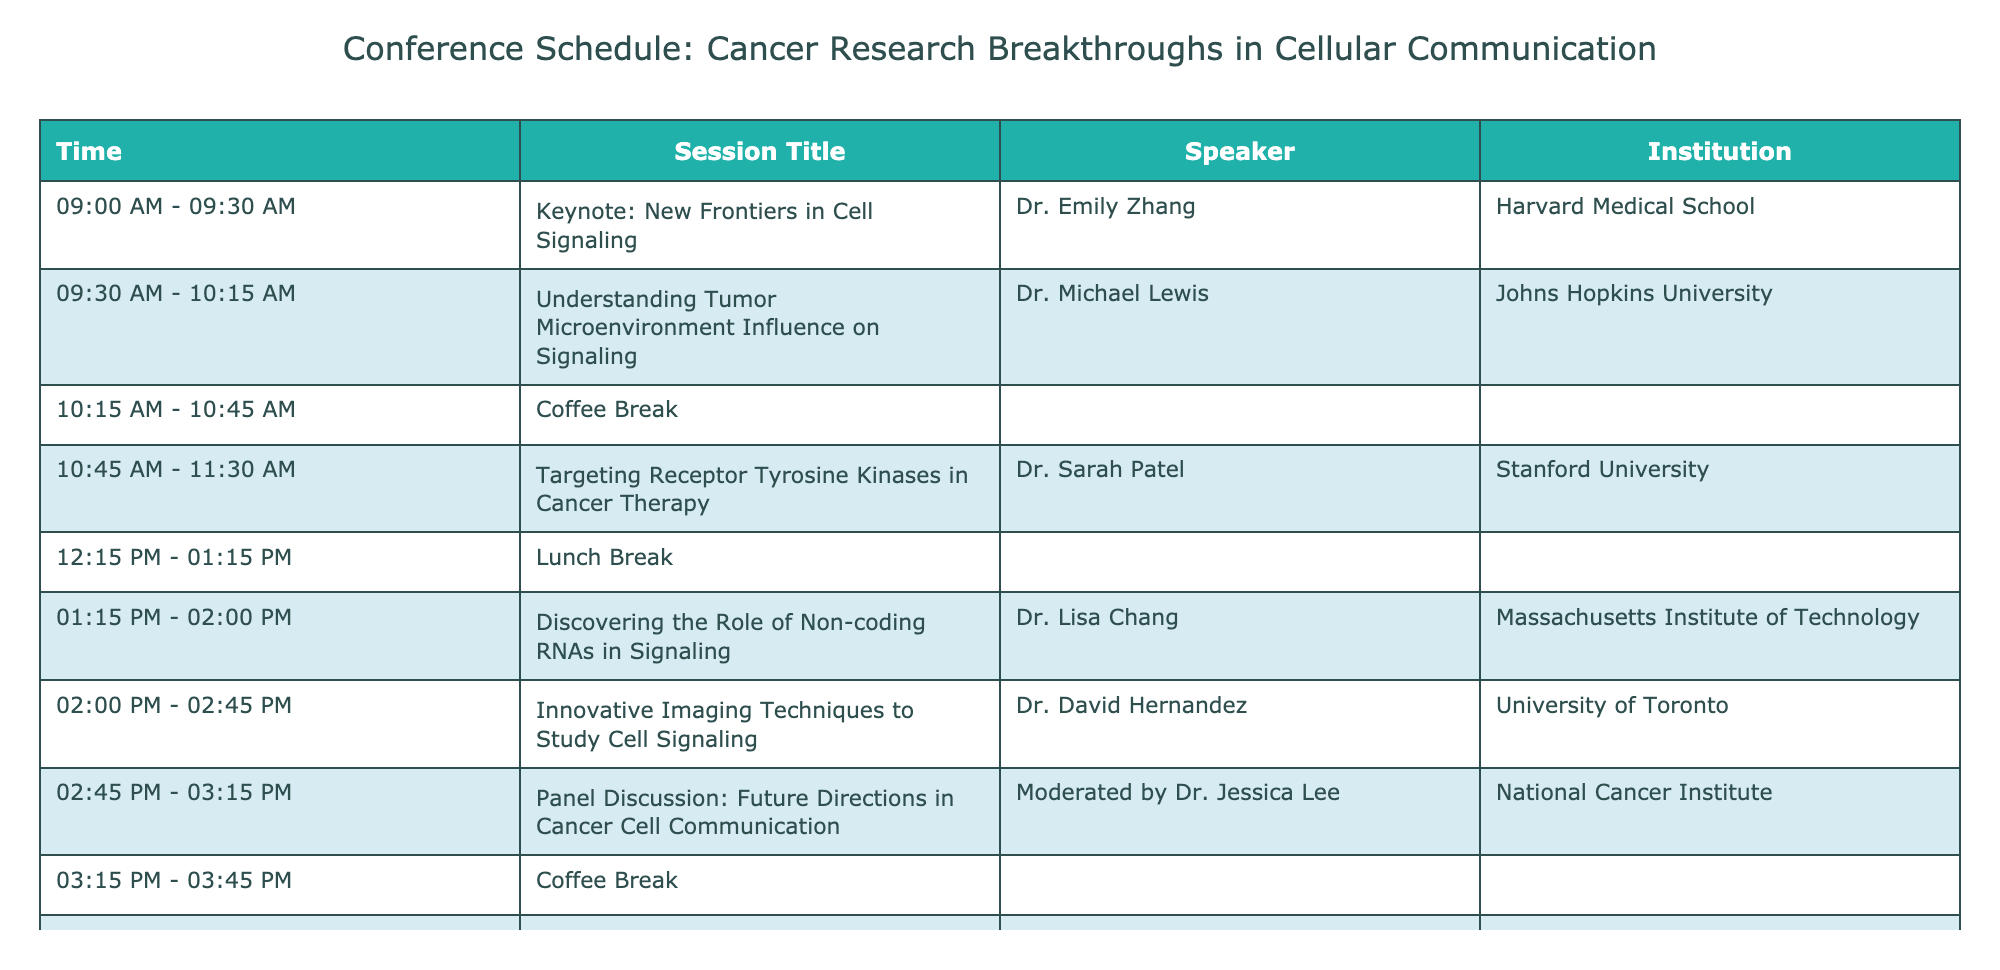What time does the keynote session start? The keynote session titled "New Frontiers in Cell Signaling" starts at 09:00 AM as listed in the 'Time' column next to the corresponding session title.
Answer: 09:00 AM Who is the speaker for the session on receptor tyrosine kinases? The session titled "Targeting Receptor Tyrosine Kinases in Cancer Therapy" features Dr. Sarah Patel as the speaker, which can be directly found in the 'Speaker' column aligned with that session title.
Answer: Dr. Sarah Patel How many sessions are scheduled after the lunch break? After the lunch break at 12:15 PM, there are three sessions: "Discovering the Role of Non-coding RNAs in Signaling," "Innovative Imaging Techniques to Study Cell Signaling," and "Panel Discussion: Future Directions in Cancer Cell Communication." Counting these sessions results in three.
Answer: 3 Is there a session discussing the tumor microenvironment? Yes, there is a session titled "Understanding Tumor Microenvironment Influence on Signaling" led by Dr. Michael Lewis, which indicates that this topic is addressed among the conference agenda.
Answer: Yes What is the duration of the coffee breaks in total? There are two coffee breaks scheduled—one from 10:15 AM to 10:45 AM (30 minutes) and another from 03:15 PM to 03:45 PM (30 minutes). Adding these two durations together gives a total coffee break time of 30 + 30 = 60 minutes.
Answer: 60 minutes Which institution is Dr. David Hernandez affiliated with? Dr. David Hernandez, who presents a session on "Innovative Imaging Techniques to Study Cell Signaling," is affiliated with the University of Toronto, as indicated in the 'Institution' column next to his name.
Answer: University of Toronto What session immediately follows the panel discussion? The session that immediately follows the panel discussion titled "Future Directions in Cancer Cell Communication" starts at 03:45 PM and is focused on utilizing CRISPR for signaling pathway discovery. This can be seen in the timeline where "Utilizing CRISPR for Signaling Pathway Discovery" is listed next.
Answer: Utilizing CRISPR for Signaling Pathway Discovery How many speakers are affiliated with Harvard Medical School? The only speaker listed from Harvard Medical School is Dr. Emily Zhang, who delivers the keynote session. Therefore, there is only one speaker from that institution according to the table.
Answer: 1 What is the title of the session directed by Dr. Lisa Chang? The session led by Dr. Lisa Chang is titled "Discovering the Role of Non-coding RNAs in Signaling," which is evident in the table where her name is associated with this specific session title.
Answer: Discovering the Role of Non-coding RNAs in Signaling 